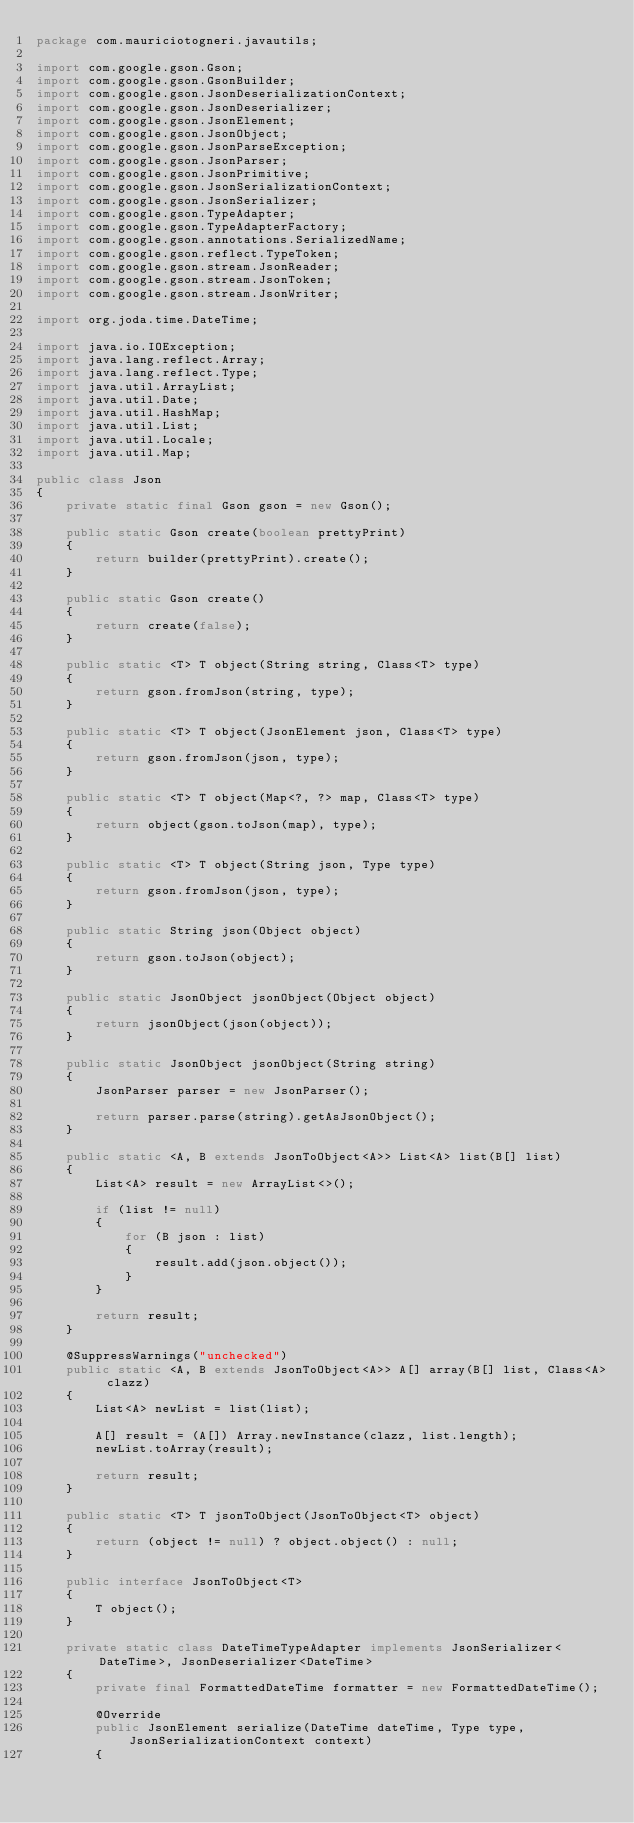<code> <loc_0><loc_0><loc_500><loc_500><_Java_>package com.mauriciotogneri.javautils;

import com.google.gson.Gson;
import com.google.gson.GsonBuilder;
import com.google.gson.JsonDeserializationContext;
import com.google.gson.JsonDeserializer;
import com.google.gson.JsonElement;
import com.google.gson.JsonObject;
import com.google.gson.JsonParseException;
import com.google.gson.JsonParser;
import com.google.gson.JsonPrimitive;
import com.google.gson.JsonSerializationContext;
import com.google.gson.JsonSerializer;
import com.google.gson.TypeAdapter;
import com.google.gson.TypeAdapterFactory;
import com.google.gson.annotations.SerializedName;
import com.google.gson.reflect.TypeToken;
import com.google.gson.stream.JsonReader;
import com.google.gson.stream.JsonToken;
import com.google.gson.stream.JsonWriter;

import org.joda.time.DateTime;

import java.io.IOException;
import java.lang.reflect.Array;
import java.lang.reflect.Type;
import java.util.ArrayList;
import java.util.Date;
import java.util.HashMap;
import java.util.List;
import java.util.Locale;
import java.util.Map;

public class Json
{
    private static final Gson gson = new Gson();

    public static Gson create(boolean prettyPrint)
    {
        return builder(prettyPrint).create();
    }

    public static Gson create()
    {
        return create(false);
    }

    public static <T> T object(String string, Class<T> type)
    {
        return gson.fromJson(string, type);
    }

    public static <T> T object(JsonElement json, Class<T> type)
    {
        return gson.fromJson(json, type);
    }

    public static <T> T object(Map<?, ?> map, Class<T> type)
    {
        return object(gson.toJson(map), type);
    }

    public static <T> T object(String json, Type type)
    {
        return gson.fromJson(json, type);
    }

    public static String json(Object object)
    {
        return gson.toJson(object);
    }

    public static JsonObject jsonObject(Object object)
    {
        return jsonObject(json(object));
    }

    public static JsonObject jsonObject(String string)
    {
        JsonParser parser = new JsonParser();

        return parser.parse(string).getAsJsonObject();
    }

    public static <A, B extends JsonToObject<A>> List<A> list(B[] list)
    {
        List<A> result = new ArrayList<>();

        if (list != null)
        {
            for (B json : list)
            {
                result.add(json.object());
            }
        }

        return result;
    }

    @SuppressWarnings("unchecked")
    public static <A, B extends JsonToObject<A>> A[] array(B[] list, Class<A> clazz)
    {
        List<A> newList = list(list);

        A[] result = (A[]) Array.newInstance(clazz, list.length);
        newList.toArray(result);

        return result;
    }

    public static <T> T jsonToObject(JsonToObject<T> object)
    {
        return (object != null) ? object.object() : null;
    }

    public interface JsonToObject<T>
    {
        T object();
    }

    private static class DateTimeTypeAdapter implements JsonSerializer<DateTime>, JsonDeserializer<DateTime>
    {
        private final FormattedDateTime formatter = new FormattedDateTime();

        @Override
        public JsonElement serialize(DateTime dateTime, Type type, JsonSerializationContext context)
        {</code> 